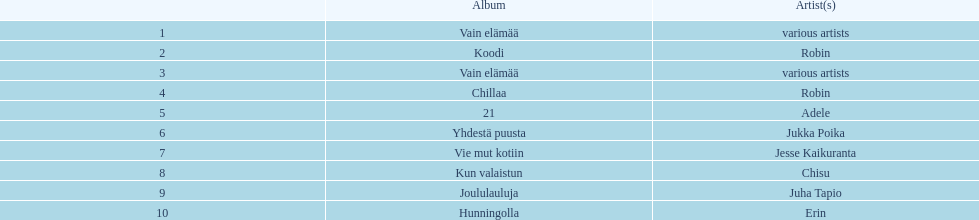What is the total number of sales for the top 10 albums? 650396. 